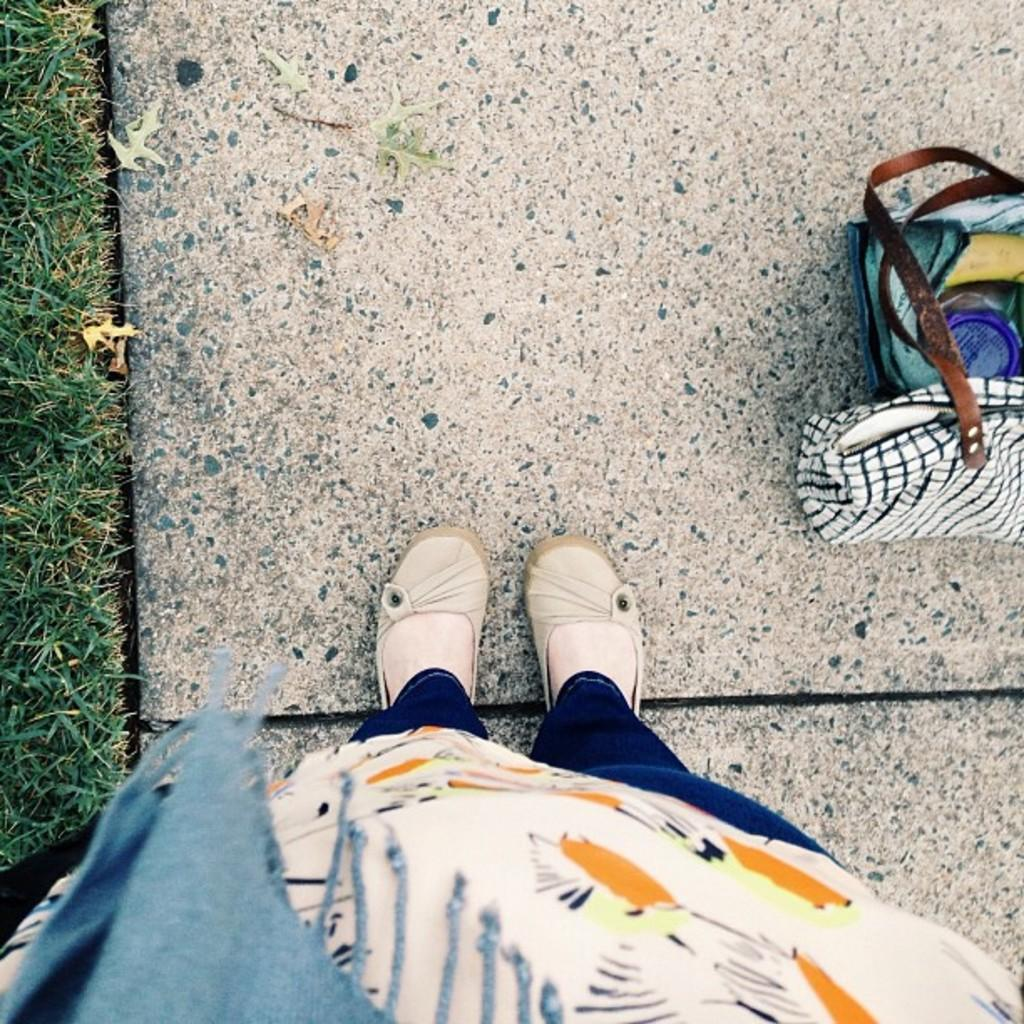What is the main subject of the image? There is a person standing in the image. Where is the person standing? The person is standing on the ground. What type of vegetation is present on the ground? There is grass and leaves on the ground. What else can be seen on the ground? There are bags on the ground. What type of drug is visible on the ground in the image? There is no drug present in the image; the ground contains grass, leaves, and bags. 